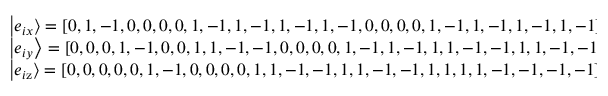<formula> <loc_0><loc_0><loc_500><loc_500>\begin{array} { l } { \left | { { e _ { i x } } } \right \rangle = { [ 0 , 1 , - 1 , 0 , 0 , 0 , 0 , 1 , - 1 , 1 , - 1 , 1 , - 1 , 1 , - 1 , 0 , 0 , 0 , 0 , 1 , - 1 , 1 , - 1 , 1 , - 1 , 1 , - 1 ] ^ { \top } } , } \\ { \left | { { e _ { i y } } } \right \rangle = { [ 0 , 0 , 0 , 1 , - 1 , 0 , 0 , 1 , 1 , - 1 , - 1 , 0 , 0 , 0 , 0 , 1 , - 1 , 1 , - 1 , 1 , 1 , - 1 , - 1 , 1 , 1 , - 1 , - 1 ] ^ { \top } } , } \\ { \left | { { e _ { i { z } } } } \right \rangle = { [ 0 , 0 , 0 , 0 , 0 , 1 , - 1 , 0 , 0 , 0 , 0 , 1 , 1 , - 1 , - 1 , 1 , 1 , - 1 , - 1 , 1 , 1 , 1 , 1 , - 1 , - 1 , - 1 , - 1 ] ^ { \top } } . } \end{array}</formula> 